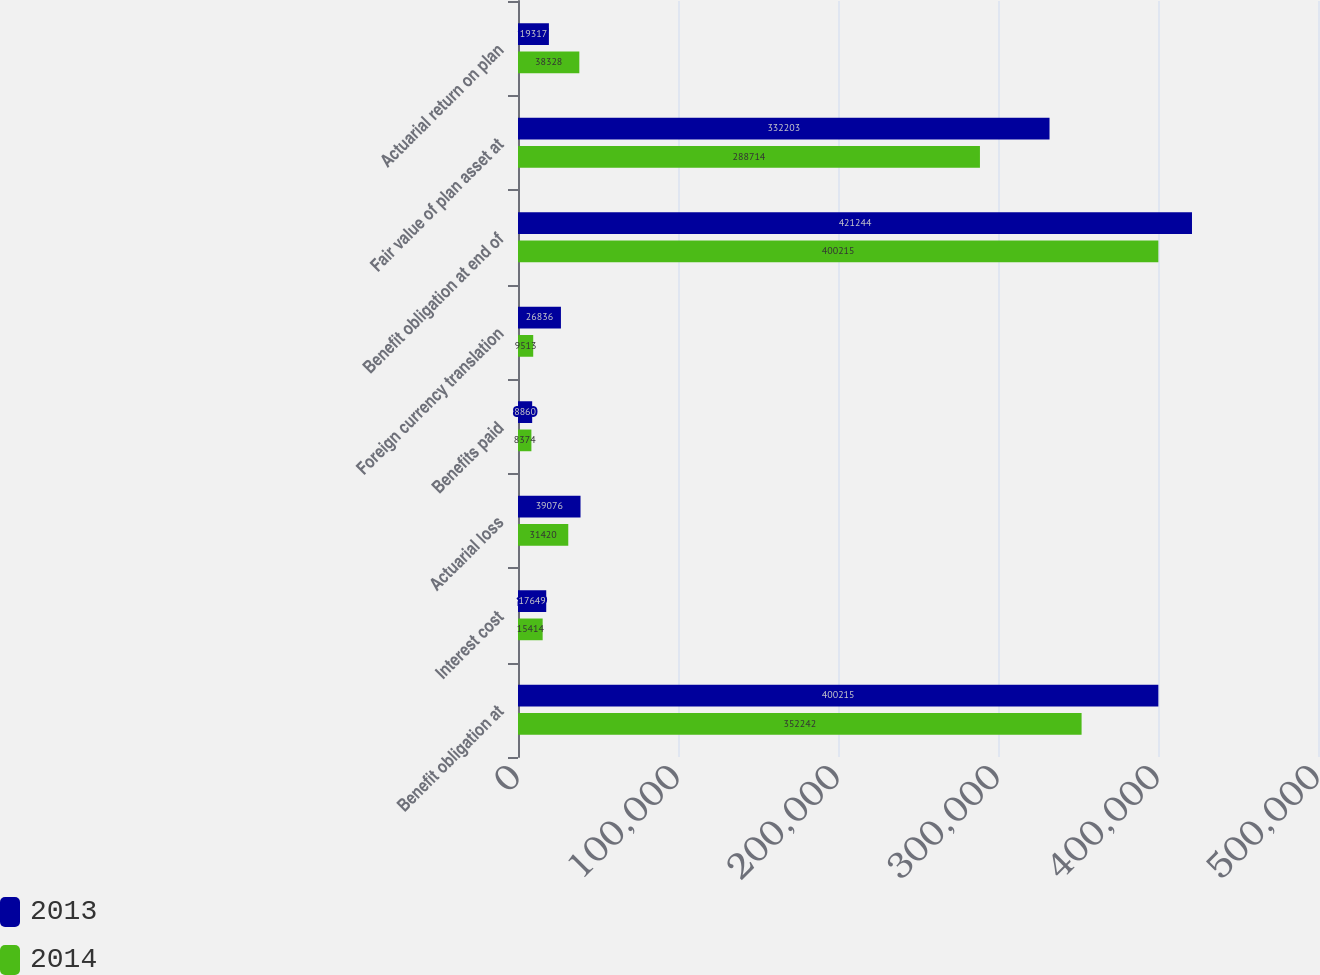<chart> <loc_0><loc_0><loc_500><loc_500><stacked_bar_chart><ecel><fcel>Benefit obligation at<fcel>Interest cost<fcel>Actuarial loss<fcel>Benefits paid<fcel>Foreign currency translation<fcel>Benefit obligation at end of<fcel>Fair value of plan asset at<fcel>Actuarial return on plan<nl><fcel>2013<fcel>400215<fcel>17649<fcel>39076<fcel>8860<fcel>26836<fcel>421244<fcel>332203<fcel>19317<nl><fcel>2014<fcel>352242<fcel>15414<fcel>31420<fcel>8374<fcel>9513<fcel>400215<fcel>288714<fcel>38328<nl></chart> 